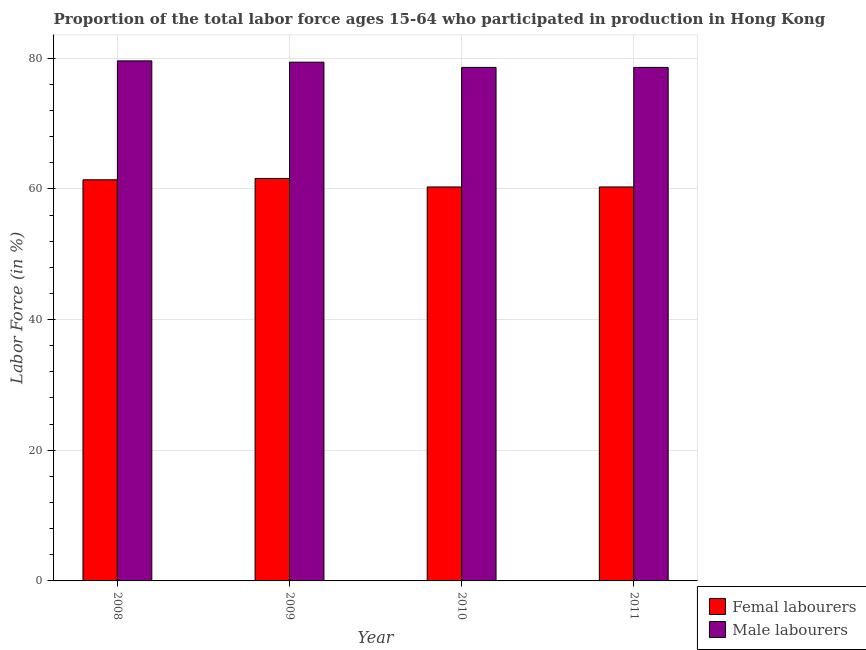How many groups of bars are there?
Provide a succinct answer. 4. Are the number of bars per tick equal to the number of legend labels?
Provide a succinct answer. Yes. Are the number of bars on each tick of the X-axis equal?
Give a very brief answer. Yes. How many bars are there on the 1st tick from the left?
Provide a succinct answer. 2. How many bars are there on the 4th tick from the right?
Offer a terse response. 2. What is the label of the 1st group of bars from the left?
Your response must be concise. 2008. In how many cases, is the number of bars for a given year not equal to the number of legend labels?
Give a very brief answer. 0. What is the percentage of male labour force in 2009?
Your answer should be very brief. 79.4. Across all years, what is the maximum percentage of female labor force?
Offer a terse response. 61.6. Across all years, what is the minimum percentage of female labor force?
Your response must be concise. 60.3. In which year was the percentage of male labour force minimum?
Ensure brevity in your answer.  2010. What is the total percentage of female labor force in the graph?
Keep it short and to the point. 243.6. What is the difference between the percentage of female labor force in 2010 and that in 2011?
Ensure brevity in your answer.  0. What is the difference between the percentage of female labor force in 2008 and the percentage of male labour force in 2009?
Provide a short and direct response. -0.2. What is the average percentage of female labor force per year?
Provide a succinct answer. 60.9. In the year 2008, what is the difference between the percentage of female labor force and percentage of male labour force?
Provide a succinct answer. 0. In how many years, is the percentage of female labor force greater than 52 %?
Ensure brevity in your answer.  4. What is the ratio of the percentage of male labour force in 2008 to that in 2009?
Your response must be concise. 1. Is the percentage of male labour force in 2009 less than that in 2011?
Make the answer very short. No. What is the difference between the highest and the second highest percentage of female labor force?
Keep it short and to the point. 0.2. What is the difference between the highest and the lowest percentage of female labor force?
Give a very brief answer. 1.3. What does the 1st bar from the left in 2009 represents?
Ensure brevity in your answer.  Femal labourers. What does the 1st bar from the right in 2011 represents?
Provide a short and direct response. Male labourers. Are all the bars in the graph horizontal?
Offer a very short reply. No. What is the difference between two consecutive major ticks on the Y-axis?
Offer a very short reply. 20. Are the values on the major ticks of Y-axis written in scientific E-notation?
Keep it short and to the point. No. Does the graph contain any zero values?
Your answer should be compact. No. Does the graph contain grids?
Your answer should be compact. Yes. Where does the legend appear in the graph?
Give a very brief answer. Bottom right. How are the legend labels stacked?
Give a very brief answer. Vertical. What is the title of the graph?
Your response must be concise. Proportion of the total labor force ages 15-64 who participated in production in Hong Kong. Does "Automatic Teller Machines" appear as one of the legend labels in the graph?
Your answer should be very brief. No. What is the Labor Force (in %) of Femal labourers in 2008?
Keep it short and to the point. 61.4. What is the Labor Force (in %) in Male labourers in 2008?
Your response must be concise. 79.6. What is the Labor Force (in %) of Femal labourers in 2009?
Ensure brevity in your answer.  61.6. What is the Labor Force (in %) of Male labourers in 2009?
Keep it short and to the point. 79.4. What is the Labor Force (in %) in Femal labourers in 2010?
Your answer should be compact. 60.3. What is the Labor Force (in %) of Male labourers in 2010?
Offer a very short reply. 78.6. What is the Labor Force (in %) in Femal labourers in 2011?
Ensure brevity in your answer.  60.3. What is the Labor Force (in %) of Male labourers in 2011?
Make the answer very short. 78.6. Across all years, what is the maximum Labor Force (in %) in Femal labourers?
Provide a short and direct response. 61.6. Across all years, what is the maximum Labor Force (in %) in Male labourers?
Your answer should be compact. 79.6. Across all years, what is the minimum Labor Force (in %) of Femal labourers?
Your answer should be compact. 60.3. Across all years, what is the minimum Labor Force (in %) in Male labourers?
Your answer should be compact. 78.6. What is the total Labor Force (in %) of Femal labourers in the graph?
Provide a succinct answer. 243.6. What is the total Labor Force (in %) in Male labourers in the graph?
Keep it short and to the point. 316.2. What is the difference between the Labor Force (in %) in Femal labourers in 2008 and that in 2009?
Your response must be concise. -0.2. What is the difference between the Labor Force (in %) of Male labourers in 2008 and that in 2009?
Your answer should be very brief. 0.2. What is the difference between the Labor Force (in %) of Femal labourers in 2008 and that in 2010?
Offer a terse response. 1.1. What is the difference between the Labor Force (in %) in Male labourers in 2008 and that in 2010?
Ensure brevity in your answer.  1. What is the difference between the Labor Force (in %) in Femal labourers in 2009 and that in 2010?
Make the answer very short. 1.3. What is the difference between the Labor Force (in %) in Male labourers in 2009 and that in 2010?
Keep it short and to the point. 0.8. What is the difference between the Labor Force (in %) in Male labourers in 2009 and that in 2011?
Offer a terse response. 0.8. What is the difference between the Labor Force (in %) in Femal labourers in 2010 and that in 2011?
Offer a very short reply. 0. What is the difference between the Labor Force (in %) in Male labourers in 2010 and that in 2011?
Your response must be concise. 0. What is the difference between the Labor Force (in %) in Femal labourers in 2008 and the Labor Force (in %) in Male labourers in 2010?
Ensure brevity in your answer.  -17.2. What is the difference between the Labor Force (in %) of Femal labourers in 2008 and the Labor Force (in %) of Male labourers in 2011?
Make the answer very short. -17.2. What is the difference between the Labor Force (in %) of Femal labourers in 2009 and the Labor Force (in %) of Male labourers in 2011?
Make the answer very short. -17. What is the difference between the Labor Force (in %) of Femal labourers in 2010 and the Labor Force (in %) of Male labourers in 2011?
Offer a very short reply. -18.3. What is the average Labor Force (in %) in Femal labourers per year?
Make the answer very short. 60.9. What is the average Labor Force (in %) of Male labourers per year?
Give a very brief answer. 79.05. In the year 2008, what is the difference between the Labor Force (in %) of Femal labourers and Labor Force (in %) of Male labourers?
Your response must be concise. -18.2. In the year 2009, what is the difference between the Labor Force (in %) in Femal labourers and Labor Force (in %) in Male labourers?
Your response must be concise. -17.8. In the year 2010, what is the difference between the Labor Force (in %) in Femal labourers and Labor Force (in %) in Male labourers?
Your answer should be compact. -18.3. In the year 2011, what is the difference between the Labor Force (in %) of Femal labourers and Labor Force (in %) of Male labourers?
Ensure brevity in your answer.  -18.3. What is the ratio of the Labor Force (in %) of Femal labourers in 2008 to that in 2009?
Keep it short and to the point. 1. What is the ratio of the Labor Force (in %) of Femal labourers in 2008 to that in 2010?
Your answer should be very brief. 1.02. What is the ratio of the Labor Force (in %) in Male labourers in 2008 to that in 2010?
Your response must be concise. 1.01. What is the ratio of the Labor Force (in %) in Femal labourers in 2008 to that in 2011?
Ensure brevity in your answer.  1.02. What is the ratio of the Labor Force (in %) of Male labourers in 2008 to that in 2011?
Keep it short and to the point. 1.01. What is the ratio of the Labor Force (in %) of Femal labourers in 2009 to that in 2010?
Your response must be concise. 1.02. What is the ratio of the Labor Force (in %) in Male labourers in 2009 to that in 2010?
Your answer should be compact. 1.01. What is the ratio of the Labor Force (in %) of Femal labourers in 2009 to that in 2011?
Offer a terse response. 1.02. What is the ratio of the Labor Force (in %) of Male labourers in 2009 to that in 2011?
Give a very brief answer. 1.01. What is the ratio of the Labor Force (in %) in Femal labourers in 2010 to that in 2011?
Keep it short and to the point. 1. What is the ratio of the Labor Force (in %) of Male labourers in 2010 to that in 2011?
Give a very brief answer. 1. What is the difference between the highest and the second highest Labor Force (in %) of Male labourers?
Offer a very short reply. 0.2. What is the difference between the highest and the lowest Labor Force (in %) of Male labourers?
Make the answer very short. 1. 